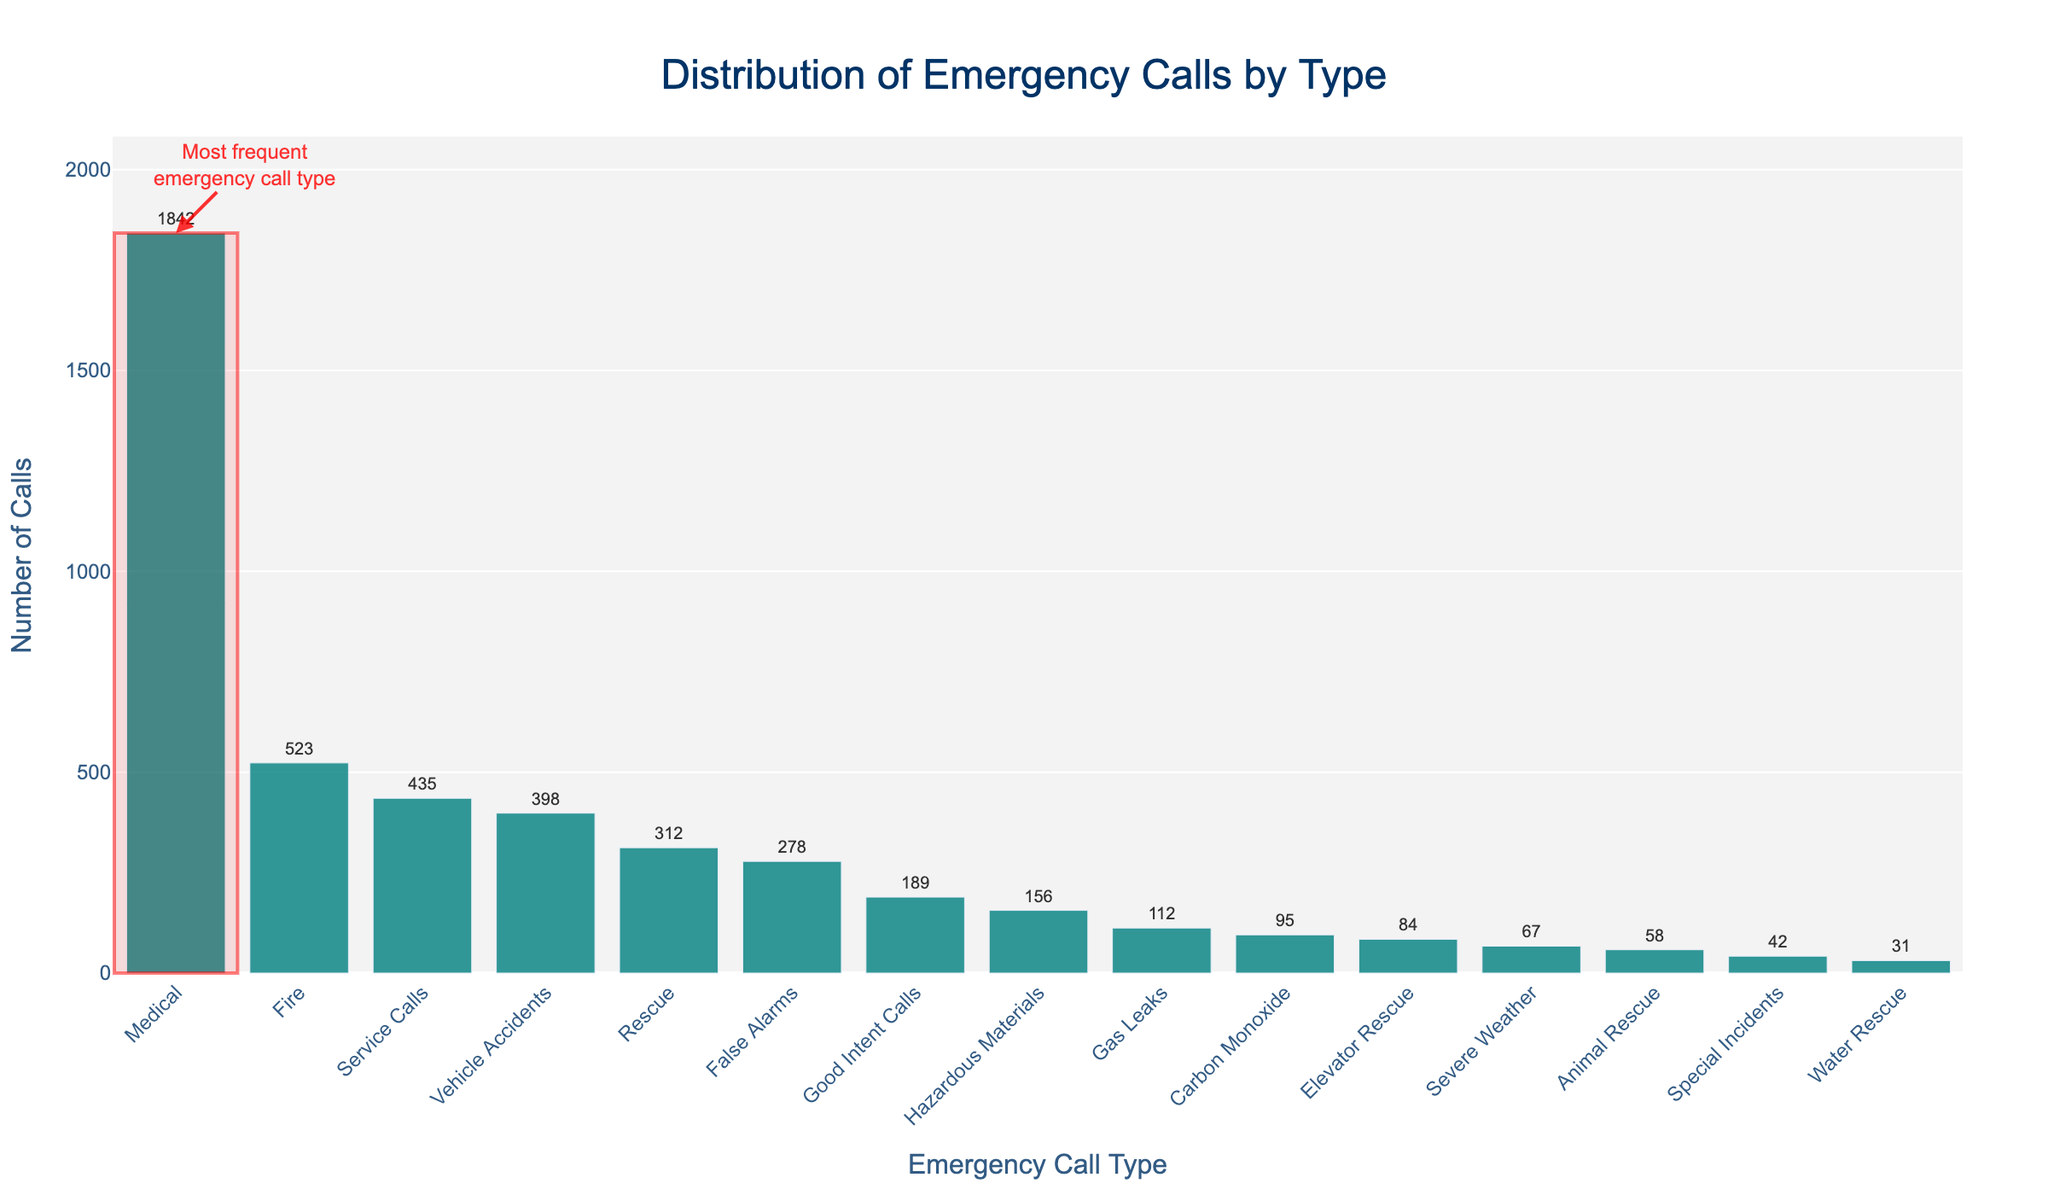What is the most frequent type of emergency call? The most frequent type of emergency call is the one with the highest bar and is also highlighted with a rectangle and annotation. This type is 'Medical' with 1842 calls.
Answer: Medical Which emergency call type has the lowest number of calls? By looking at the shortest bar, we can see that 'Special Incidents' has the lowest number of calls with just 42.
Answer: Special Incidents What is the total number of calls for 'Rescue', 'Vehicle Accidents', and 'Animal Rescue'? The number of calls for 'Rescue' is 312, 'Vehicle Accidents' is 398, and 'Animal Rescue' is 58. Adding these values: 312 + 398 + 58 = 768.
Answer: 768 How many more medical calls were there compared to fire calls? The number of medical calls is 1842 and fire calls is 523. Subtracting these values: 1842 - 523 = 1319.
Answer: 1319 Is the number of false alarms greater than the number of gas leaks? The number of false alarms is 278 and the number of gas leaks is 112. Since 278 is greater than 112, the answer is yes.
Answer: Yes What percentage of the total emergency calls are 'Service Calls'? The total number of calls can be calculated by summing all call types: 523 + 1842 + 312 + 156 + 435 + 278 + 189 + 67 + 42 + 398 + 95 + 31 + 84 + 58 + 112 = 4622. The number of service calls is 435. The percentage is (435 / 4622) * 100 ≈ 9.41%.
Answer: 9.41% Which type of rescue calls is more frequent: 'Water Rescue' or 'Elevator Rescue'? Comparing the heights of the bars, 'Elevator Rescue' has more calls (84) compared to 'Water Rescue' (31).
Answer: Elevator Rescue If you combine the calls for 'False Alarms' and 'Good Intent Calls', are they still fewer than the 'Rescue' calls? The number of calls for 'False Alarms' is 278 and for 'Good Intent Calls' is 189. Adding these values: 278 + 189 = 467. The number of 'Rescue' calls is 312. Since 467 is greater than 312, the answer is no.
Answer: No How does the number of 'Hazardous Materials' calls compare to 'Carbon Monoxide' calls? The number of 'Hazardous Materials' calls is 156 and 'Carbon Monoxide' calls is 95. 156 is greater than 95.
Answer: 156 is greater What is the combined number of calls for 'Fire' and 'Severe Weather'? The number of 'Fire' calls is 523 and 'Severe Weather' calls is 67. Adding these values: 523 + 67 = 590.
Answer: 590 